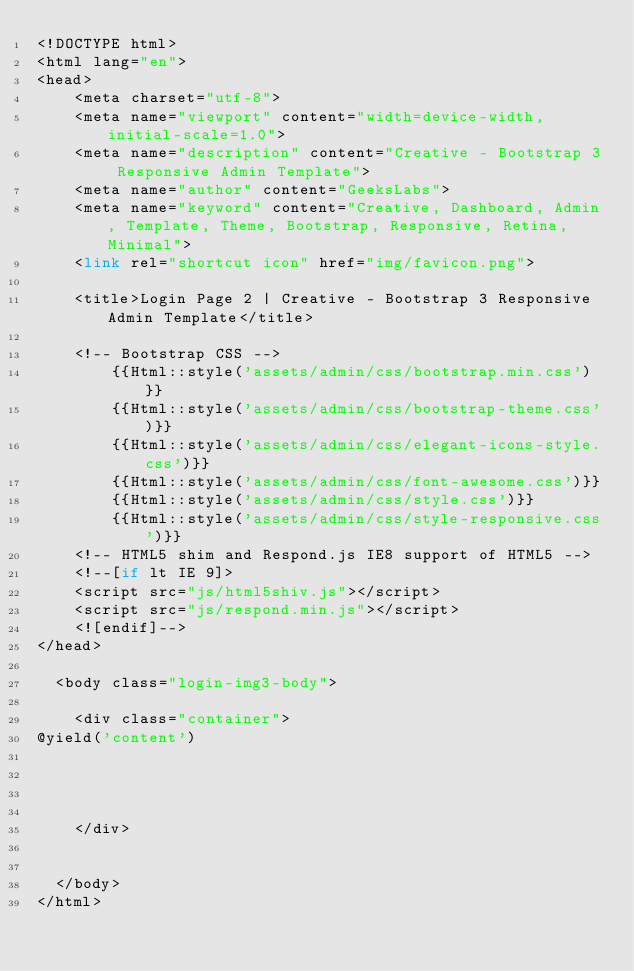<code> <loc_0><loc_0><loc_500><loc_500><_PHP_><!DOCTYPE html>
<html lang="en">
<head>
    <meta charset="utf-8">
    <meta name="viewport" content="width=device-width, initial-scale=1.0">
    <meta name="description" content="Creative - Bootstrap 3 Responsive Admin Template">
    <meta name="author" content="GeeksLabs">
    <meta name="keyword" content="Creative, Dashboard, Admin, Template, Theme, Bootstrap, Responsive, Retina, Minimal">
    <link rel="shortcut icon" href="img/favicon.png">

    <title>Login Page 2 | Creative - Bootstrap 3 Responsive Admin Template</title>

    <!-- Bootstrap CSS -->  
        {{Html::style('assets/admin/css/bootstrap.min.css')}}
        {{Html::style('assets/admin/css/bootstrap-theme.css')}}
        {{Html::style('assets/admin/css/elegant-icons-style.css')}}
        {{Html::style('assets/admin/css/font-awesome.css')}}
        {{Html::style('assets/admin/css/style.css')}}
        {{Html::style('assets/admin/css/style-responsive.css')}}
    <!-- HTML5 shim and Respond.js IE8 support of HTML5 -->
    <!--[if lt IE 9]>
    <script src="js/html5shiv.js"></script>
    <script src="js/respond.min.js"></script>
    <![endif]-->
</head>

  <body class="login-img3-body">

    <div class="container">
@yield('content')


   

    </div>


  </body>
</html>
</code> 